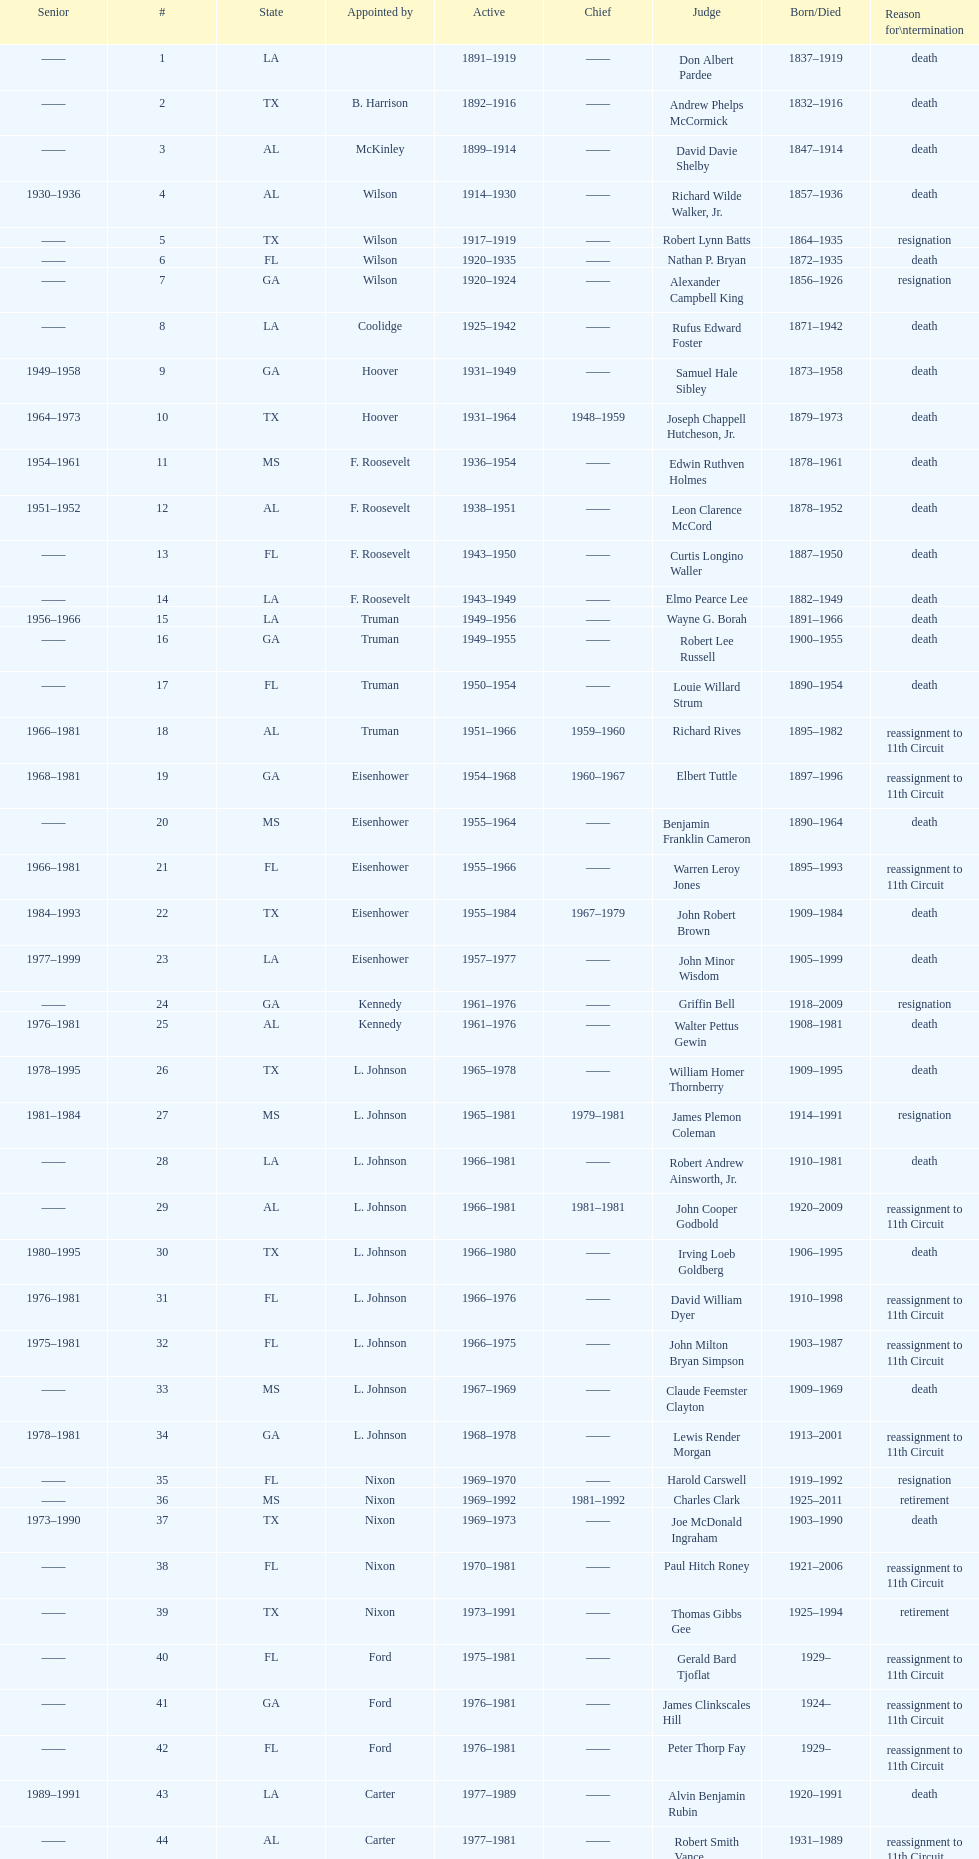Who was the only judge appointed by mckinley? David Davie Shelby. 